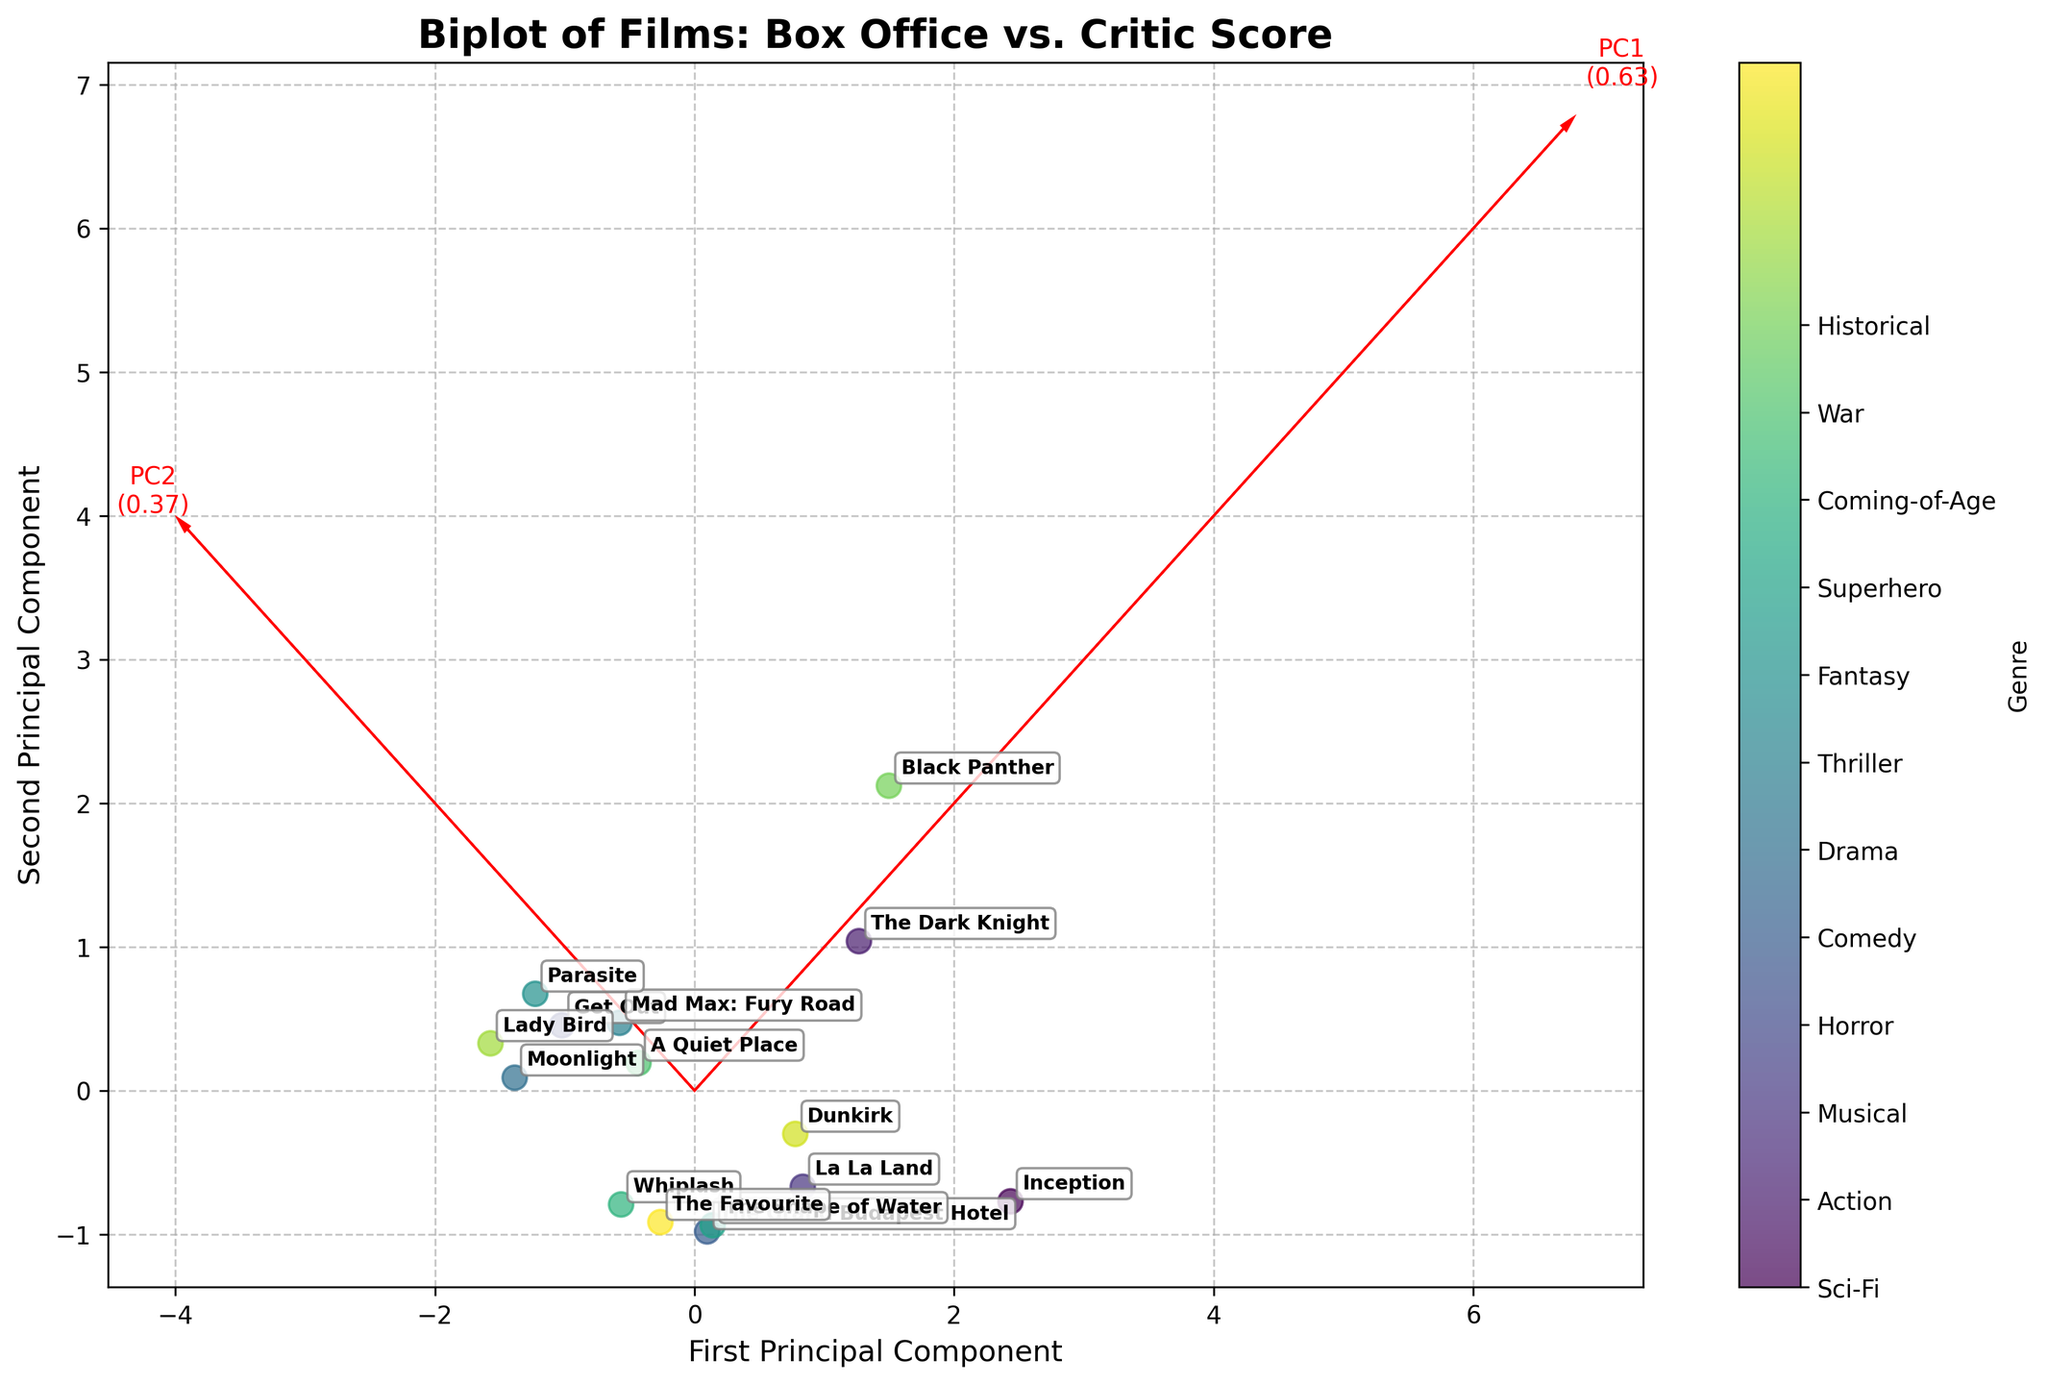What's the title of the figure? The title is usually located at the top of the figure, which summarizes its content. Reading the title at the top, we find it states the purpose and data of the plot.
Answer: Biplot of Films: Box Office vs. Critic Score Which axis represents the first principal component? The labels for the axes indicate what they represent. The x-axis label identifies it as the First Principal Component.
Answer: x-axis How many genres are represented in the plot? The plot includes a colorbar that labels different genres. Counting these labels will give us the answer.
Answer: 8 Which film has the highest box office performance? The plot uses arrows labeled with the films' names. The length of arrows and their direction toward positive values of PCA components can indicate performance. The film positioned furthest in the BoxOffice direction on the first PCA component shows the highest box office performance.
Answer: Black Panther Which two films are closest on the biplot? Proximity on the plot means the films' corresponding coordinates are very close. Identify the films with annotations closest in Euclidean distance on the biplot.
Answer: Get Out and Parasite Is there a general pattern between genres in terms of box office performance? Observe the distribution and clustering of genres in the plot. Determine if films of the same genre appear grouped in similar box office performance regions.
Answer: Action and Superhero films tend to have higher box office performance Which genre has the highest critic scores generally? Look at the position of the films on the Second Principal Component direction, indicating higher Critic Scores. Identify the genre that appears highest on this axis.
Answer: Horror and Coming-of-Age Do fantasy films cluster together on the plot? Check the position of the films labeled as Fantasy. If most of these films are close to each other, it suggests clustering.
Answer: No Between "Inception" and "La La Land," which had higher critic scores? Locate the positions of "Inception" and "La La Land" on the plot. Identify which of the two is positioned higher along the y-axis (Second Principal Component) correlating to higher critic scores.
Answer: La La Land Which film is located furthest from the origin? The distance from the origin to each film's point can be visually estimated. The film farthest from zero along both axes is the correct answer.
Answer: Black Panther 